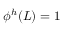<formula> <loc_0><loc_0><loc_500><loc_500>\phi ^ { h } ( L ) = 1</formula> 